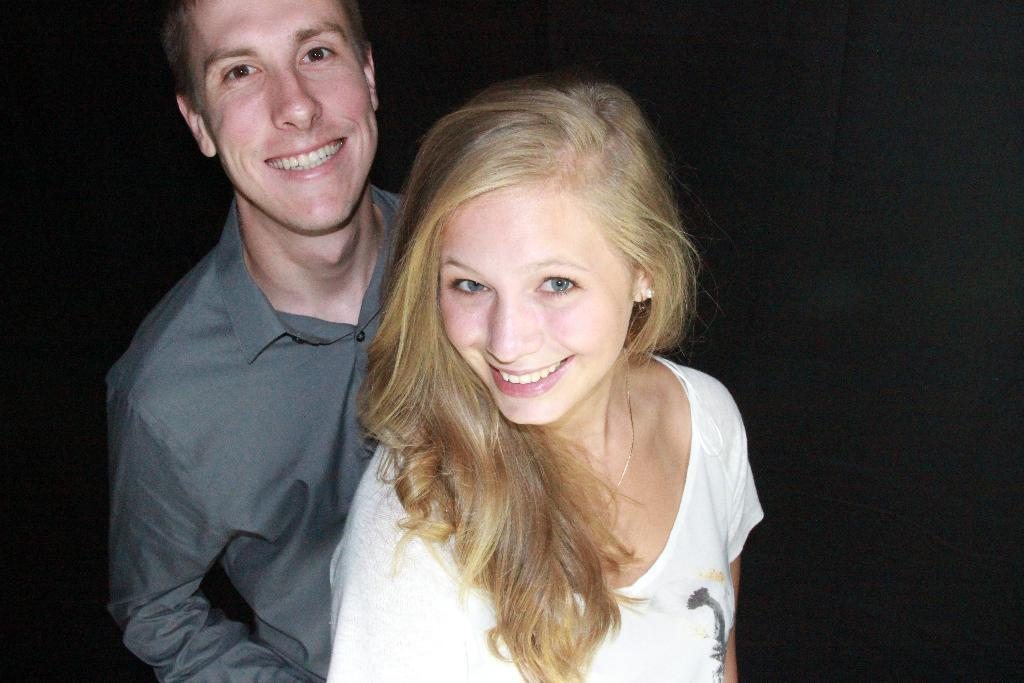How many people are in the image? There are two persons in the image. What are the two persons doing in the image? The two persons are standing. What is the facial expression of the two persons in the image? The two persons are smiling. What type of dog is present in the image? There is no dog present in the image; it features two standing and smiling persons. What fact can be learned about the activity of the persons in the image? The provided facts do not mention any specific activity that the persons are engaged in. 